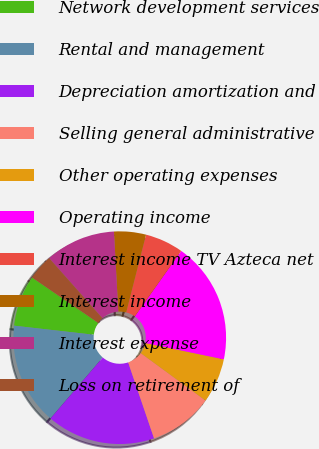Convert chart. <chart><loc_0><loc_0><loc_500><loc_500><pie_chart><fcel>Network development services<fcel>Rental and management<fcel>Depreciation amortization and<fcel>Selling general administrative<fcel>Other operating expenses<fcel>Operating income<fcel>Interest income TV Azteca net<fcel>Interest income<fcel>Interest expense<fcel>Loss on retirement of<nl><fcel>7.77%<fcel>15.53%<fcel>16.5%<fcel>9.71%<fcel>6.8%<fcel>18.45%<fcel>5.83%<fcel>4.85%<fcel>10.68%<fcel>3.88%<nl></chart> 